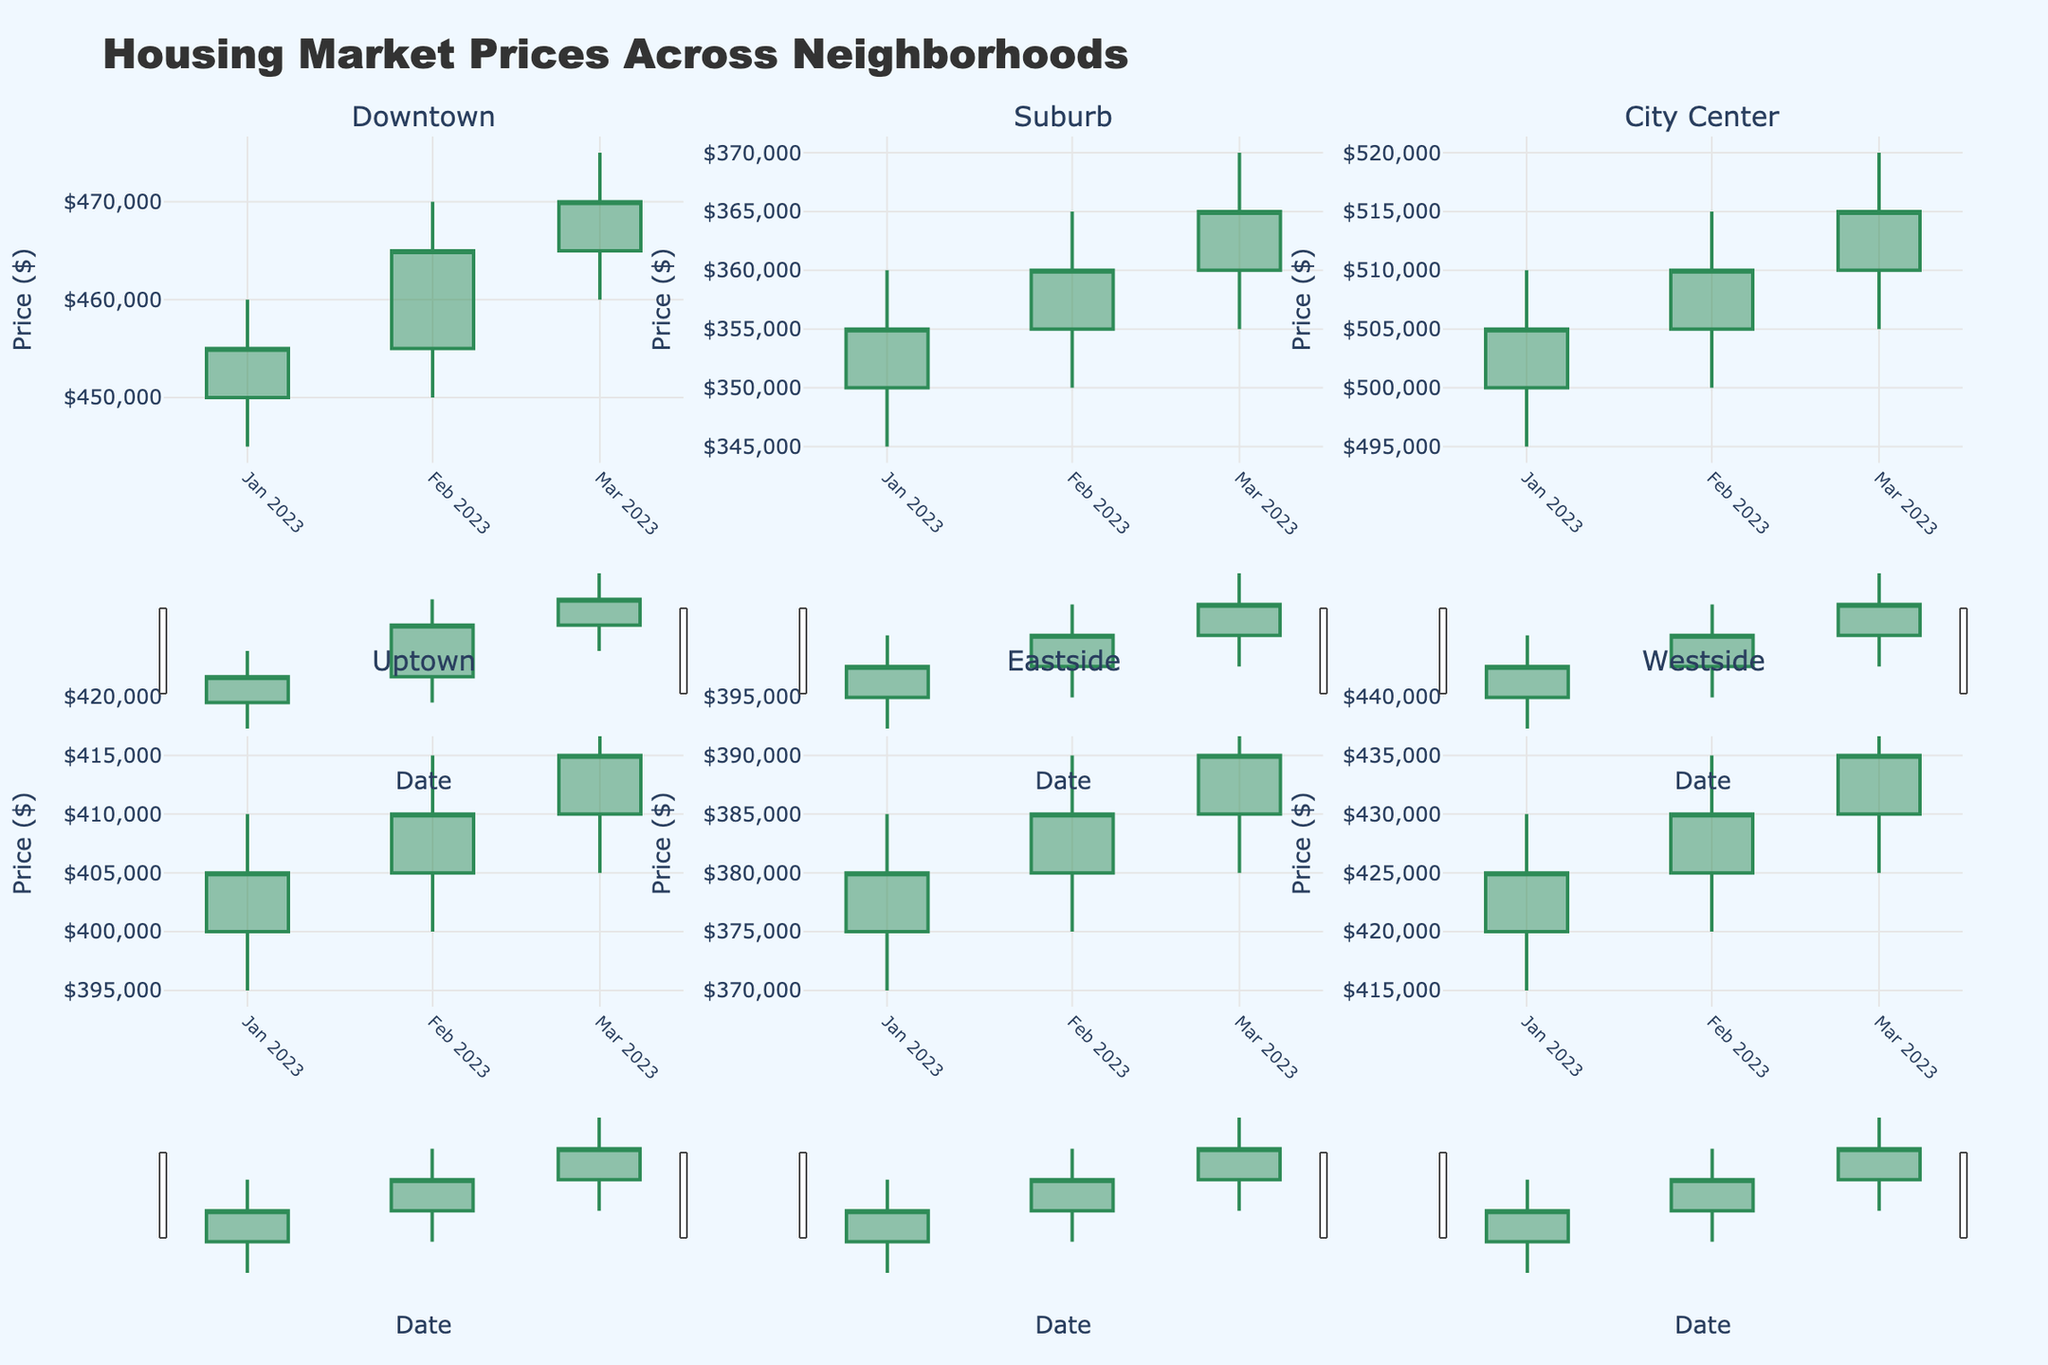What is the title of the figure? The title of a figure is usually found at the top or the header of the plot. In this case, it reads "Housing Market Prices Across Neighborhoods."
Answer: Housing Market Prices Across Neighborhoods How many neighborhoods are displayed in the figure? By counting the subplot titles, you can see six neighborhood names: Downtown, Suburb, City Center, Uptown, Eastside, and Westside.
Answer: Six What are the colors indicating increasing and decreasing prices in the candlestick plots? The colors for the increasing and decreasing prices are given in the plot legend or through observation. The increasing prices are #2E8B57 (green) and the decreasing prices are #B22222 (red).
Answer: Green for increasing and Red for decreasing Which neighborhood had the highest closing price at any point? To find the highest closing price, look for the highest point on the "Close" axis. City Center had a closing price of $515,000, which is the highest among all neighborhoods.
Answer: City Center What was the opening price for Downtown in January 2023? Refer to the candlestick plot for Downtown in January 2023. The opening price is represented by the bottom edge of the thick vertical bar.
Answer: $450,000 Compare the closing prices of Downtown and Uptown in March 2023. Which was higher? Look at the closing prices for both Downtown and Uptown in March 2023. Downtown's closing price was $470,000 and Uptown's was $415,000. Since $470,000 is greater than $415,000, Downtown's closing price was higher.
Answer: Downtown What is the difference between the highest and lowest values for Eastside in February 2023? For Eastside in February 2023, the highest value is $390,000 and the lowest is $375,000. The difference is calculated as $390,000 - $375,000 = $15,000.
Answer: $15,000 Which month had the smallest range in prices for Suburb? The range is calculated by subtracting the lowest price from the highest price for each month. In January, the range is $360,000 - $345,000 = $15,000; in February, it's $365,000 - $350,000 = $15,000; in March, it's $370,000 - $355,000 = $15,000. All months have the same range of $15,000.
Answer: All months Did the closing price for Westside increase or decrease from January to February 2023? Compare the closing prices for Westside from January ($425,000) to February ($430,000). The price increased since $430,000 is greater than $425,000.
Answer: Increased Which neighborhood had the most stable price trends? To determine stability, look for neighborhoods with the smallest fluctuations between open, high, low, and close prices. Suburb displays the smallest variations and most stable trends over the three months.
Answer: Suburb 